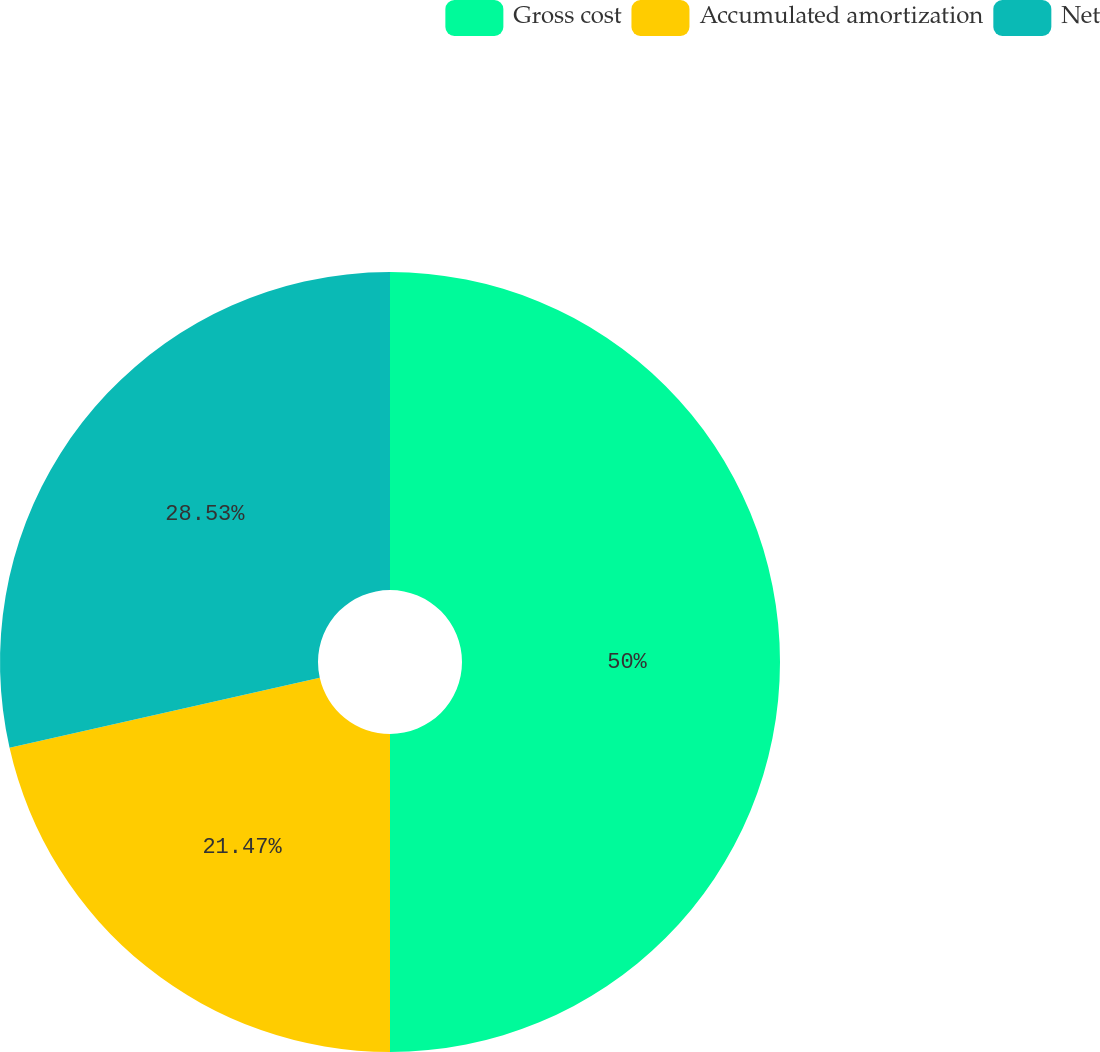Convert chart. <chart><loc_0><loc_0><loc_500><loc_500><pie_chart><fcel>Gross cost<fcel>Accumulated amortization<fcel>Net<nl><fcel>50.0%<fcel>21.47%<fcel>28.53%<nl></chart> 